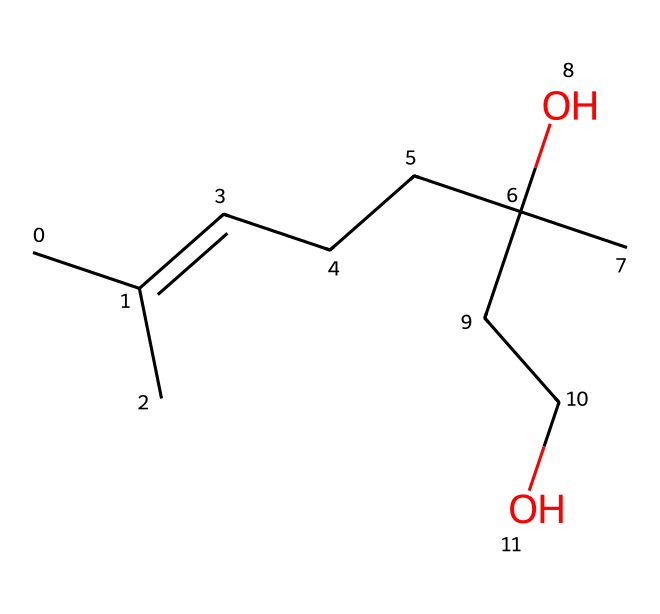What is the molecular formula of citronellol? By analyzing the SMILES representation CC(C)=CCCC(C)(O)CCO, we can deduce the number of carbon (C), hydrogen (H), and oxygen (O) atoms present. There are 10 carbon atoms, 18 hydrogen atoms, and 2 oxygen atoms, resulting in the molecular formula C10H18O2.
Answer: C10H18O2 How many carbon atoms are in citronellol? The SMILES notation indicates the number of carbon atoms by counting 'C' symbols. In this case, there are 10 carbon symbols.
Answer: 10 How many hydroxyl (OH) groups are in the molecule? Examining the SMILES representation, we see there are two oxygen atoms (O) in the structure, with one being part of a hydroxyl group (-OH). Therefore, there is one hydroxyl group in citronellol.
Answer: 1 What type of compound is citronellol? Citronellol, as indicated by its structure containing a hydroxyl (-OH) group and multiple carbon chains, is classified as an alcohol due to the presence of that functional group.
Answer: alcohol Is citronellol likely to be hydrophilic or hydrophobic? Given the presence of a hydroxyl group in the structure, which increases polarity, citronellol is likely hydrophilic. The long carbon chains contribute some hydrophobic character, but the -OH group prevails in making the molecule hydrophilic.
Answer: hydrophilic What structural feature in citronellol contributes to its mosquito-repellent properties? The presence of the hydroxyl (-OH) group is key to the biological activity and effectiveness of citronellol as a natural mosquito repellent, making the structure attractive to the target species.
Answer: hydroxyl group 